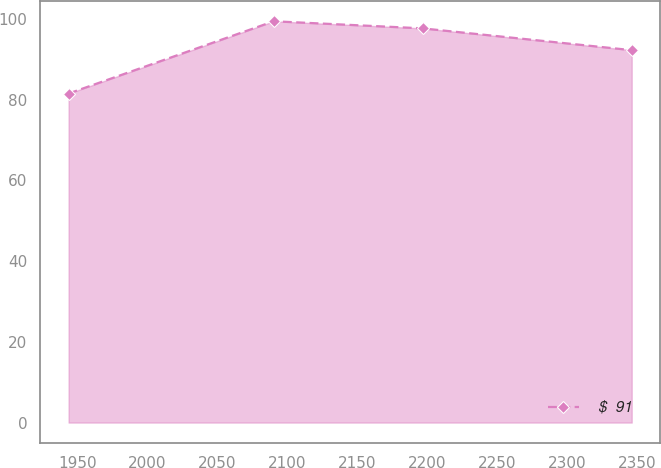Convert chart. <chart><loc_0><loc_0><loc_500><loc_500><line_chart><ecel><fcel>$  91<nl><fcel>1943.76<fcel>81.52<nl><fcel>2090.32<fcel>99.42<nl><fcel>2196.65<fcel>97.66<nl><fcel>2346.09<fcel>92.26<nl></chart> 